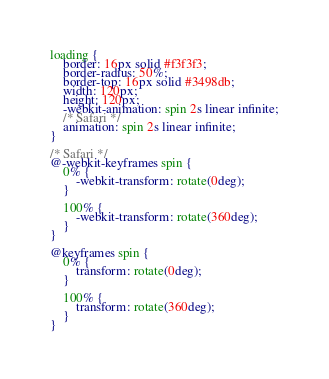<code> <loc_0><loc_0><loc_500><loc_500><_CSS_>loading {
    border: 16px solid #f3f3f3;
    border-radius: 50%;
    border-top: 16px solid #3498db;
    width: 120px;
    height: 120px;
    -webkit-animation: spin 2s linear infinite;
    /* Safari */
    animation: spin 2s linear infinite;
}

/* Safari */
@-webkit-keyframes spin {
    0% {
        -webkit-transform: rotate(0deg);
    }

    100% {
        -webkit-transform: rotate(360deg);
    }
}

@keyframes spin {
    0% {
        transform: rotate(0deg);
    }

    100% {
        transform: rotate(360deg);
    }
}</code> 